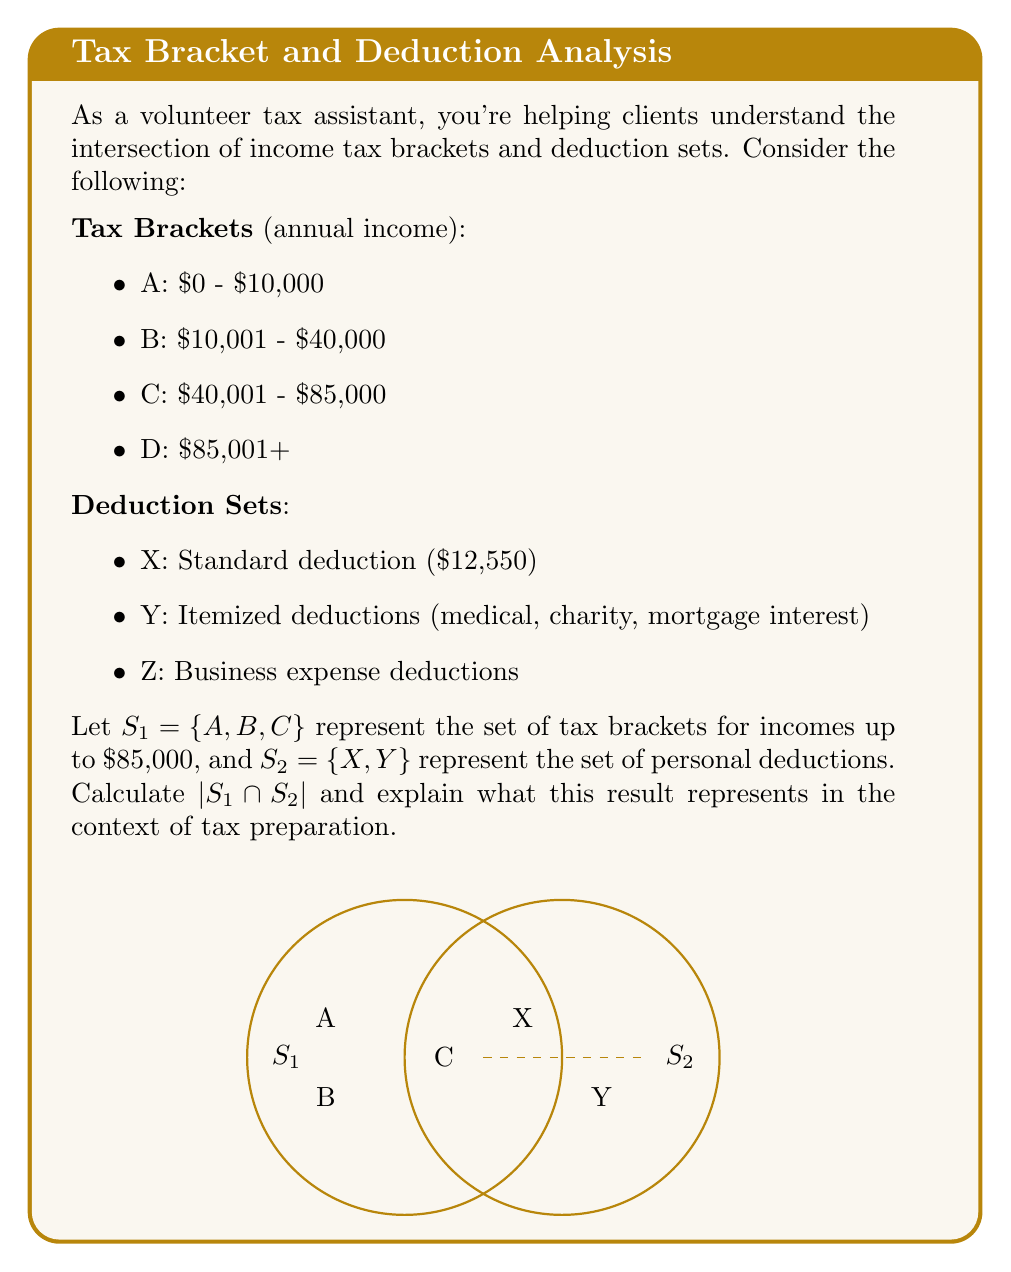What is the answer to this math problem? To solve this problem, we need to understand the concepts of sets and their intersections in the context of tax brackets and deductions.

1) First, let's identify the elements of each set:
   $S_1 = \{A, B, C\}$ (tax brackets up to $85,000)
   $S_2 = \{X, Y\}$ (personal deductions)

2) The intersection of two sets, denoted by $\cap$, is the set of elements that are common to both sets.

3) In this case, $S_1$ and $S_2$ represent different types of tax concepts (brackets and deductions). They do not have any common elements.

4) Therefore, $S_1 \cap S_2 = \emptyset$ (the empty set)

5) The cardinality of a set, denoted by $|\cdot|$, is the number of elements in the set.

6) Since $S_1 \cap S_2$ is the empty set, $|S_1 \cap S_2| = 0$

In the context of tax preparation, this result ($|S_1 \cap S_2| = 0$) indicates that tax brackets and personal deductions are distinct concepts that do not directly overlap. This means that:

a) A taxpayer's income bracket (from $S_1$) is determined independently of their choice of deductions (from $S_2$).
b) The choice between standard and itemized deductions (elements of $S_2$) doesn't directly affect which tax bracket (elements of $S_1$) a person falls into.
c) However, deductions can indirectly affect the tax bracket by reducing taxable income, which is an important consideration for tax planning.
Answer: $|S_1 \cap S_2| = 0$ 